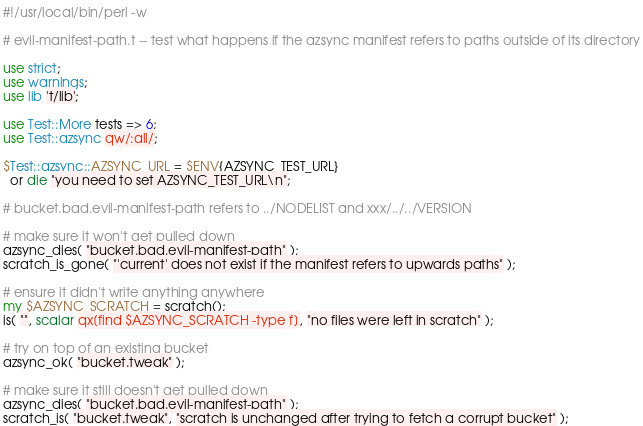Convert code to text. <code><loc_0><loc_0><loc_500><loc_500><_Perl_>#!/usr/local/bin/perl -w

# evil-manifest-path.t -- test what happens if the azsync manifest refers to paths outside of its directory

use strict;
use warnings;
use lib 't/lib';

use Test::More tests => 6;
use Test::azsync qw/:all/;

$Test::azsync::AZSYNC_URL = $ENV{AZSYNC_TEST_URL}
  or die "you need to set AZSYNC_TEST_URL\n";

# bucket.bad.evil-manifest-path refers to ../NODELIST and xxx/../../VERSION

# make sure it won't get pulled down
azsync_dies( "bucket.bad.evil-manifest-path" );
scratch_is_gone( "'current' does not exist if the manifest refers to upwards paths" );

# ensure it didn't write anything anywhere
my $AZSYNC_SCRATCH = scratch();
is( "", scalar qx[find $AZSYNC_SCRATCH -type f], "no files were left in scratch" );

# try on top of an existing bucket
azsync_ok( "bucket.tweak" );

# make sure it still doesn't get pulled down
azsync_dies( "bucket.bad.evil-manifest-path" );
scratch_is( "bucket.tweak", "scratch is unchanged after trying to fetch a corrupt bucket" );
</code> 